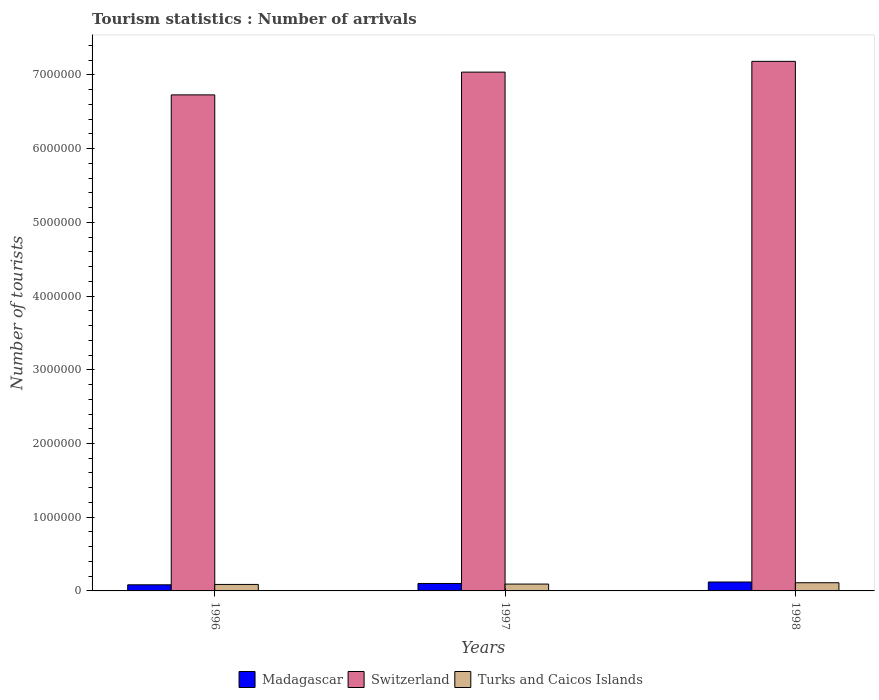How many different coloured bars are there?
Make the answer very short. 3. Are the number of bars per tick equal to the number of legend labels?
Your response must be concise. Yes. What is the number of tourist arrivals in Madagascar in 1998?
Provide a short and direct response. 1.21e+05. Across all years, what is the maximum number of tourist arrivals in Turks and Caicos Islands?
Your answer should be compact. 1.11e+05. Across all years, what is the minimum number of tourist arrivals in Turks and Caicos Islands?
Provide a short and direct response. 8.80e+04. What is the total number of tourist arrivals in Madagascar in the graph?
Keep it short and to the point. 3.05e+05. What is the difference between the number of tourist arrivals in Madagascar in 1997 and that in 1998?
Your response must be concise. -2.00e+04. What is the difference between the number of tourist arrivals in Turks and Caicos Islands in 1998 and the number of tourist arrivals in Switzerland in 1996?
Your answer should be very brief. -6.62e+06. What is the average number of tourist arrivals in Switzerland per year?
Your answer should be very brief. 6.98e+06. In the year 1997, what is the difference between the number of tourist arrivals in Madagascar and number of tourist arrivals in Switzerland?
Make the answer very short. -6.94e+06. In how many years, is the number of tourist arrivals in Turks and Caicos Islands greater than 200000?
Keep it short and to the point. 0. What is the ratio of the number of tourist arrivals in Turks and Caicos Islands in 1996 to that in 1997?
Provide a succinct answer. 0.95. Is the difference between the number of tourist arrivals in Madagascar in 1996 and 1997 greater than the difference between the number of tourist arrivals in Switzerland in 1996 and 1997?
Give a very brief answer. Yes. What is the difference between the highest and the second highest number of tourist arrivals in Switzerland?
Your answer should be compact. 1.46e+05. What is the difference between the highest and the lowest number of tourist arrivals in Switzerland?
Your answer should be very brief. 4.55e+05. Is the sum of the number of tourist arrivals in Switzerland in 1997 and 1998 greater than the maximum number of tourist arrivals in Madagascar across all years?
Keep it short and to the point. Yes. What does the 1st bar from the left in 1997 represents?
Your answer should be very brief. Madagascar. What does the 2nd bar from the right in 1998 represents?
Your answer should be compact. Switzerland. Is it the case that in every year, the sum of the number of tourist arrivals in Switzerland and number of tourist arrivals in Turks and Caicos Islands is greater than the number of tourist arrivals in Madagascar?
Make the answer very short. Yes. How many bars are there?
Give a very brief answer. 9. Are all the bars in the graph horizontal?
Offer a very short reply. No. How many years are there in the graph?
Give a very brief answer. 3. Does the graph contain any zero values?
Make the answer very short. No. Does the graph contain grids?
Your answer should be compact. No. How many legend labels are there?
Provide a succinct answer. 3. What is the title of the graph?
Keep it short and to the point. Tourism statistics : Number of arrivals. Does "Sierra Leone" appear as one of the legend labels in the graph?
Ensure brevity in your answer.  No. What is the label or title of the Y-axis?
Offer a very short reply. Number of tourists. What is the Number of tourists in Madagascar in 1996?
Ensure brevity in your answer.  8.30e+04. What is the Number of tourists of Switzerland in 1996?
Give a very brief answer. 6.73e+06. What is the Number of tourists in Turks and Caicos Islands in 1996?
Your response must be concise. 8.80e+04. What is the Number of tourists of Madagascar in 1997?
Ensure brevity in your answer.  1.01e+05. What is the Number of tourists of Switzerland in 1997?
Your answer should be very brief. 7.04e+06. What is the Number of tourists in Turks and Caicos Islands in 1997?
Offer a terse response. 9.30e+04. What is the Number of tourists in Madagascar in 1998?
Keep it short and to the point. 1.21e+05. What is the Number of tourists in Switzerland in 1998?
Give a very brief answer. 7.18e+06. What is the Number of tourists of Turks and Caicos Islands in 1998?
Your response must be concise. 1.11e+05. Across all years, what is the maximum Number of tourists of Madagascar?
Your response must be concise. 1.21e+05. Across all years, what is the maximum Number of tourists of Switzerland?
Provide a succinct answer. 7.18e+06. Across all years, what is the maximum Number of tourists of Turks and Caicos Islands?
Ensure brevity in your answer.  1.11e+05. Across all years, what is the minimum Number of tourists of Madagascar?
Provide a succinct answer. 8.30e+04. Across all years, what is the minimum Number of tourists of Switzerland?
Provide a succinct answer. 6.73e+06. Across all years, what is the minimum Number of tourists in Turks and Caicos Islands?
Your answer should be compact. 8.80e+04. What is the total Number of tourists in Madagascar in the graph?
Your answer should be compact. 3.05e+05. What is the total Number of tourists of Switzerland in the graph?
Make the answer very short. 2.10e+07. What is the total Number of tourists of Turks and Caicos Islands in the graph?
Your answer should be very brief. 2.92e+05. What is the difference between the Number of tourists of Madagascar in 1996 and that in 1997?
Your answer should be very brief. -1.80e+04. What is the difference between the Number of tourists in Switzerland in 1996 and that in 1997?
Provide a succinct answer. -3.09e+05. What is the difference between the Number of tourists of Turks and Caicos Islands in 1996 and that in 1997?
Ensure brevity in your answer.  -5000. What is the difference between the Number of tourists of Madagascar in 1996 and that in 1998?
Provide a short and direct response. -3.80e+04. What is the difference between the Number of tourists of Switzerland in 1996 and that in 1998?
Make the answer very short. -4.55e+05. What is the difference between the Number of tourists of Turks and Caicos Islands in 1996 and that in 1998?
Keep it short and to the point. -2.30e+04. What is the difference between the Number of tourists of Madagascar in 1997 and that in 1998?
Your answer should be compact. -2.00e+04. What is the difference between the Number of tourists of Switzerland in 1997 and that in 1998?
Provide a succinct answer. -1.46e+05. What is the difference between the Number of tourists of Turks and Caicos Islands in 1997 and that in 1998?
Make the answer very short. -1.80e+04. What is the difference between the Number of tourists in Madagascar in 1996 and the Number of tourists in Switzerland in 1997?
Offer a terse response. -6.96e+06. What is the difference between the Number of tourists of Switzerland in 1996 and the Number of tourists of Turks and Caicos Islands in 1997?
Make the answer very short. 6.64e+06. What is the difference between the Number of tourists in Madagascar in 1996 and the Number of tourists in Switzerland in 1998?
Keep it short and to the point. -7.10e+06. What is the difference between the Number of tourists in Madagascar in 1996 and the Number of tourists in Turks and Caicos Islands in 1998?
Your response must be concise. -2.80e+04. What is the difference between the Number of tourists in Switzerland in 1996 and the Number of tourists in Turks and Caicos Islands in 1998?
Provide a short and direct response. 6.62e+06. What is the difference between the Number of tourists of Madagascar in 1997 and the Number of tourists of Switzerland in 1998?
Offer a very short reply. -7.08e+06. What is the difference between the Number of tourists in Switzerland in 1997 and the Number of tourists in Turks and Caicos Islands in 1998?
Your response must be concise. 6.93e+06. What is the average Number of tourists in Madagascar per year?
Offer a very short reply. 1.02e+05. What is the average Number of tourists of Switzerland per year?
Your answer should be compact. 6.98e+06. What is the average Number of tourists in Turks and Caicos Islands per year?
Keep it short and to the point. 9.73e+04. In the year 1996, what is the difference between the Number of tourists in Madagascar and Number of tourists in Switzerland?
Give a very brief answer. -6.65e+06. In the year 1996, what is the difference between the Number of tourists of Madagascar and Number of tourists of Turks and Caicos Islands?
Your answer should be very brief. -5000. In the year 1996, what is the difference between the Number of tourists in Switzerland and Number of tourists in Turks and Caicos Islands?
Ensure brevity in your answer.  6.64e+06. In the year 1997, what is the difference between the Number of tourists of Madagascar and Number of tourists of Switzerland?
Provide a succinct answer. -6.94e+06. In the year 1997, what is the difference between the Number of tourists in Madagascar and Number of tourists in Turks and Caicos Islands?
Your answer should be very brief. 8000. In the year 1997, what is the difference between the Number of tourists in Switzerland and Number of tourists in Turks and Caicos Islands?
Make the answer very short. 6.95e+06. In the year 1998, what is the difference between the Number of tourists in Madagascar and Number of tourists in Switzerland?
Your answer should be very brief. -7.06e+06. In the year 1998, what is the difference between the Number of tourists in Madagascar and Number of tourists in Turks and Caicos Islands?
Ensure brevity in your answer.  10000. In the year 1998, what is the difference between the Number of tourists in Switzerland and Number of tourists in Turks and Caicos Islands?
Make the answer very short. 7.07e+06. What is the ratio of the Number of tourists of Madagascar in 1996 to that in 1997?
Provide a short and direct response. 0.82. What is the ratio of the Number of tourists in Switzerland in 1996 to that in 1997?
Your response must be concise. 0.96. What is the ratio of the Number of tourists in Turks and Caicos Islands in 1996 to that in 1997?
Give a very brief answer. 0.95. What is the ratio of the Number of tourists of Madagascar in 1996 to that in 1998?
Provide a succinct answer. 0.69. What is the ratio of the Number of tourists in Switzerland in 1996 to that in 1998?
Provide a short and direct response. 0.94. What is the ratio of the Number of tourists in Turks and Caicos Islands in 1996 to that in 1998?
Provide a succinct answer. 0.79. What is the ratio of the Number of tourists of Madagascar in 1997 to that in 1998?
Provide a short and direct response. 0.83. What is the ratio of the Number of tourists of Switzerland in 1997 to that in 1998?
Keep it short and to the point. 0.98. What is the ratio of the Number of tourists of Turks and Caicos Islands in 1997 to that in 1998?
Give a very brief answer. 0.84. What is the difference between the highest and the second highest Number of tourists of Madagascar?
Your answer should be very brief. 2.00e+04. What is the difference between the highest and the second highest Number of tourists in Switzerland?
Offer a very short reply. 1.46e+05. What is the difference between the highest and the second highest Number of tourists of Turks and Caicos Islands?
Provide a succinct answer. 1.80e+04. What is the difference between the highest and the lowest Number of tourists of Madagascar?
Keep it short and to the point. 3.80e+04. What is the difference between the highest and the lowest Number of tourists in Switzerland?
Give a very brief answer. 4.55e+05. What is the difference between the highest and the lowest Number of tourists of Turks and Caicos Islands?
Your response must be concise. 2.30e+04. 